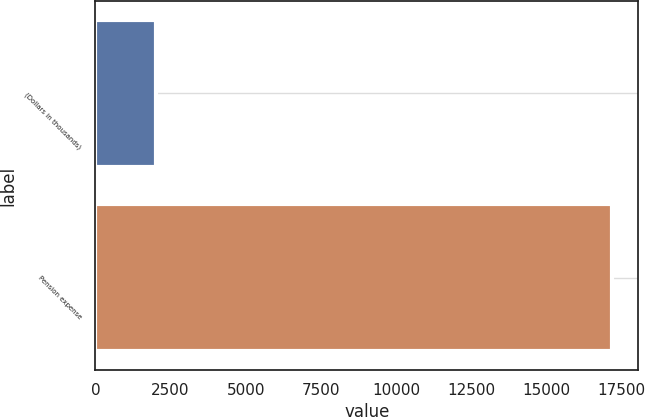Convert chart to OTSL. <chart><loc_0><loc_0><loc_500><loc_500><bar_chart><fcel>(Dollars in thousands)<fcel>Pension expense<nl><fcel>2016<fcel>17188<nl></chart> 